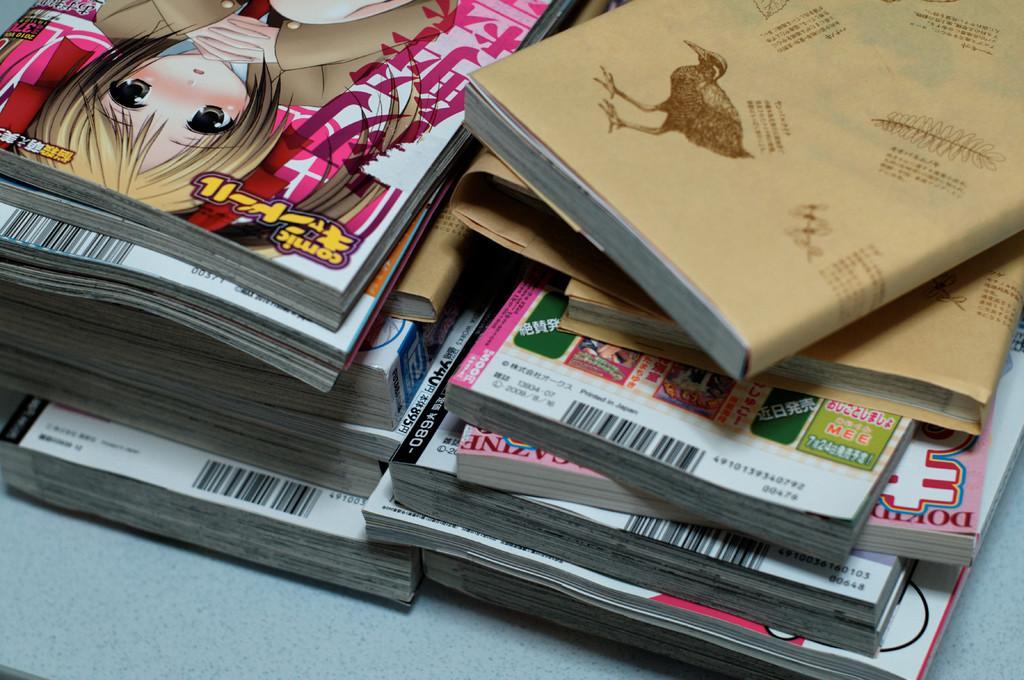How would you summarize this image in a sentence or two? In this image I see number of books and on this book I see the cartoon character of a girl and I see something is written on few books and I see the depiction of the bird on this book. 